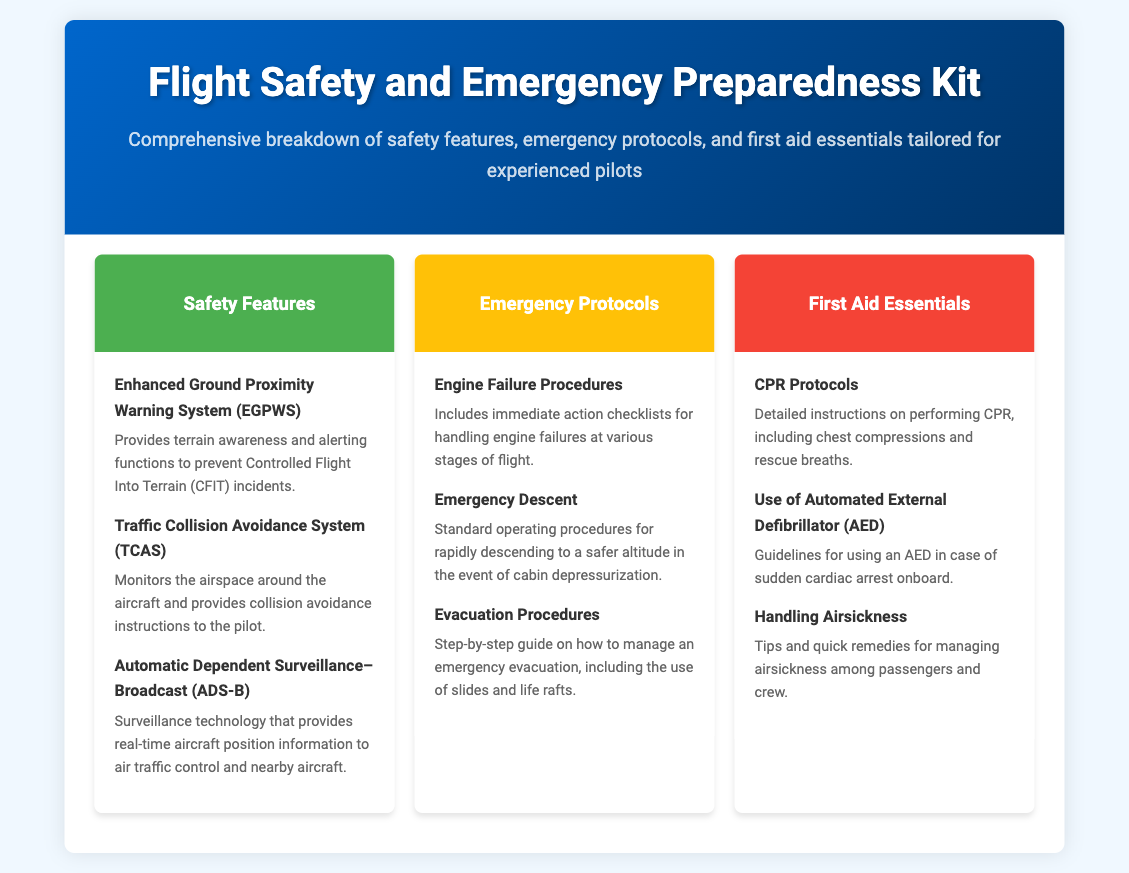What are the three sections of the kit? The document outlines three sections: Safety Features, Emergency Protocols, and First Aid Essentials.
Answer: Safety Features, Emergency Protocols, First Aid Essentials How many items are listed under Safety Features? There are three items detailed under the Safety Features section.
Answer: 3 What safety feature helps prevent CFIT incidents? The specific safety feature that helps prevent CFIT incidents is the Enhanced Ground Proximity Warning System (EGPWS).
Answer: Enhanced Ground Proximity Warning System (EGPWS) What is covered under Emergency Protocols for engine failures? The document mentions immediate action checklists for handling engine failures at various stages of flight under Emergency Protocols.
Answer: Immediate action checklists Which item provides guidelines for sudden cardiac arrest? The use of Automated External Defibrillator (AED) offers guidelines for sudden cardiac arrest.
Answer: Use of Automated External Defibrillator (AED) What color represents the First Aid Essentials section? The First Aid Essentials section is represented by the color red, specifically #F44336.
Answer: Red (#F44336) 